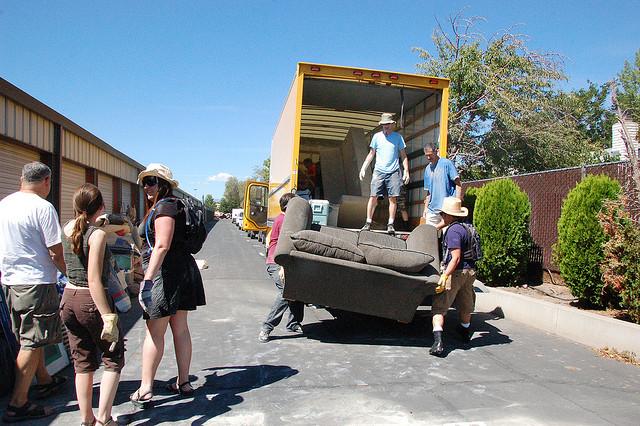What are they putting on the truck?
Write a very short answer. Couch. How many men are in the truck?
Write a very short answer. 2. Is there any women?
Concise answer only. Yes. 